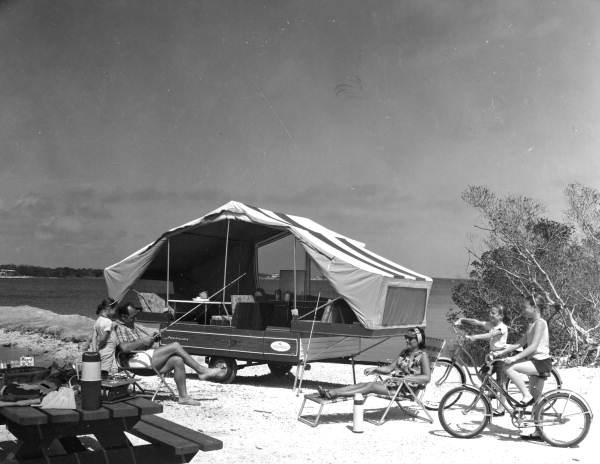Are these people camping?
Short answer required. Yes. Would this be adequate shelter if it started storming?
Answer briefly. No. How many people are in this photo?
Write a very short answer. 5. 